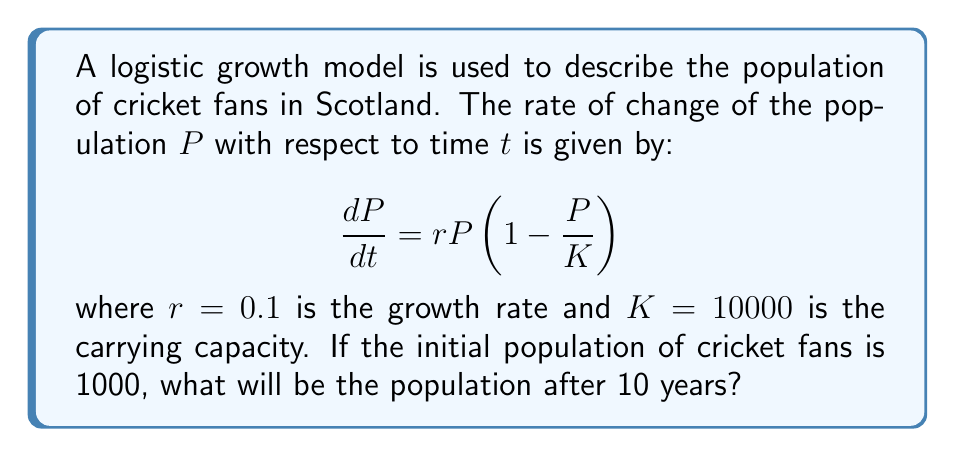Can you answer this question? To solve this problem, we need to use the logistic growth equation and its solution:

1. The logistic growth equation is given by:
   $$\frac{dP}{dt} = rP\left(1 - \frac{P}{K}\right)$$

2. The solution to this equation is:
   $$P(t) = \frac{K}{1 + \left(\frac{K}{P_0} - 1\right)e^{-rt}}$$

   where $P_0$ is the initial population.

3. We are given:
   $r = 0.1$ (growth rate)
   $K = 10000$ (carrying capacity)
   $P_0 = 1000$ (initial population)
   $t = 10$ (time in years)

4. Substituting these values into the solution:
   $$P(10) = \frac{10000}{1 + \left(\frac{10000}{1000} - 1\right)e^{-0.1 \cdot 10}}$$

5. Simplify:
   $$P(10) = \frac{10000}{1 + 9e^{-1}}$$

6. Calculate:
   $$P(10) \approx 7311.37$$

7. Round to the nearest whole number:
   $$P(10) \approx 7311$$
Answer: 7311 cricket fans 